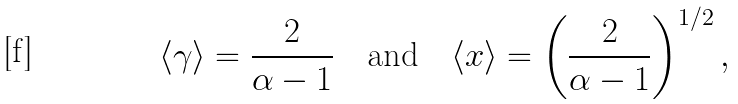<formula> <loc_0><loc_0><loc_500><loc_500>\langle \gamma \rangle = \frac { 2 } { \alpha - 1 } \quad \text {and} \quad \langle x \rangle = \left ( \frac { 2 } { \alpha - 1 } \right ) ^ { 1 / 2 } ,</formula> 